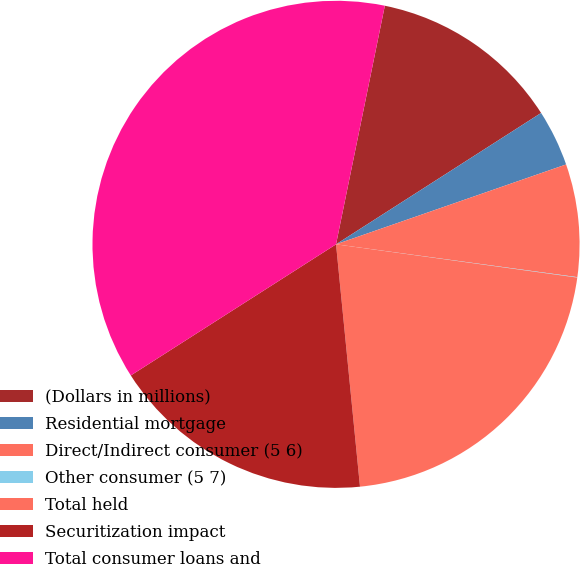<chart> <loc_0><loc_0><loc_500><loc_500><pie_chart><fcel>(Dollars in millions)<fcel>Residential mortgage<fcel>Direct/Indirect consumer (5 6)<fcel>Other consumer (5 7)<fcel>Total held<fcel>Securitization impact<fcel>Total consumer loans and<nl><fcel>12.72%<fcel>3.75%<fcel>7.47%<fcel>0.03%<fcel>21.25%<fcel>17.52%<fcel>37.26%<nl></chart> 